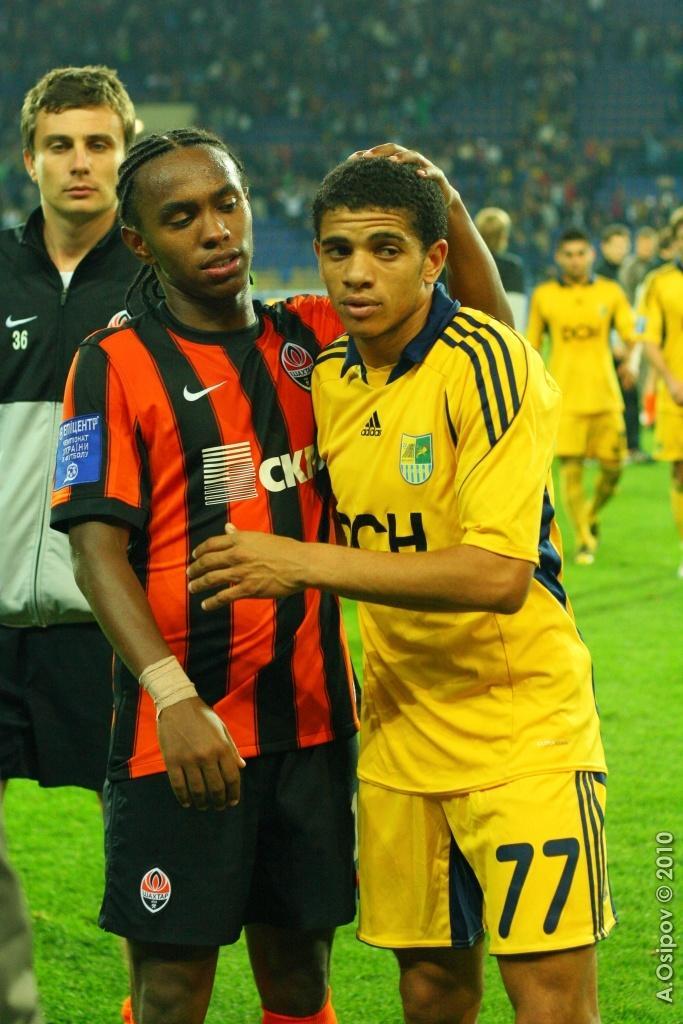How would you summarize this image in a sentence or two? In the image we can see three men standing and wearing clothes. Behind them there are other people walking, they are wearing clothes, socks and shoes. Here we can see grass and on the bottom right we can see the watermark. The background is slightly blurred. 